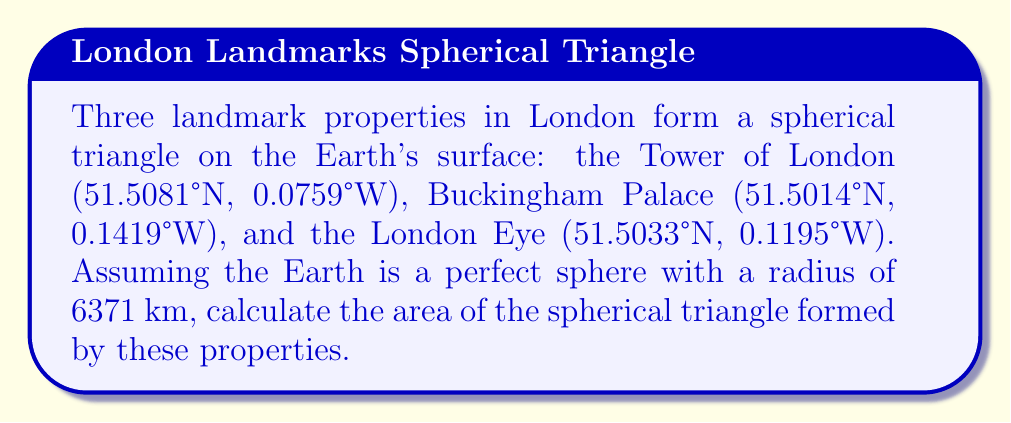Give your solution to this math problem. To solve this problem, we'll use the spherical excess formula and follow these steps:

1) Convert the coordinates to radians:
   Tower of London: $\lambda_1 = -0.001325$, $\phi_1 = 0.898952$
   Buckingham Palace: $\lambda_2 = -0.002477$, $\phi_2 = 0.898528$
   London Eye: $\lambda_3 = -0.002086$, $\phi_3 = 0.898822$

2) Calculate the lengths of the sides (central angles) using the great circle distance formula:
   $$\cos(c) = \sin(\phi_1)\sin(\phi_2) + \cos(\phi_1)\cos(\phi_2)\cos(\lambda_2 - \lambda_1)$$

   $a = 0.001629$ (Tower of London to London Eye)
   $b = 0.000810$ (London Eye to Buckingham Palace)
   $c = 0.001153$ (Buckingham Palace to Tower of London)

3) Calculate the spherical excess $E$ using l'Huilier's formula:
   $$\tan(\frac{E}{4}) = \sqrt{\tan(\frac{s}{2})\tan(\frac{s-a}{2})\tan(\frac{s-b}{2})\tan(\frac{s-c}{2})}$$
   where $s = \frac{a+b+c}{2}$ is the semi-perimeter.

   $s = 0.001796$
   $E = 1.4387 \times 10^{-7}$ radians

4) Calculate the area using the spherical excess formula:
   $$A = R^2 E$$
   where $R$ is the radius of the Earth (6371 km).

   $A = 6371^2 \times 1.4387 \times 10^{-7} = 5.8397$ km²
Answer: 5.8397 km² 